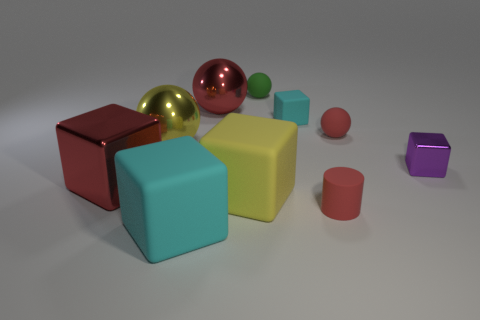Subtract all blue spheres. How many cyan blocks are left? 2 Subtract all large yellow balls. How many balls are left? 3 Subtract all green balls. How many balls are left? 3 Subtract all cyan blocks. Subtract all gray balls. How many blocks are left? 3 Subtract all spheres. How many objects are left? 6 Subtract all big matte cubes. Subtract all big red metallic things. How many objects are left? 6 Add 2 yellow matte blocks. How many yellow matte blocks are left? 3 Add 7 tiny rubber cylinders. How many tiny rubber cylinders exist? 8 Subtract 0 purple balls. How many objects are left? 10 